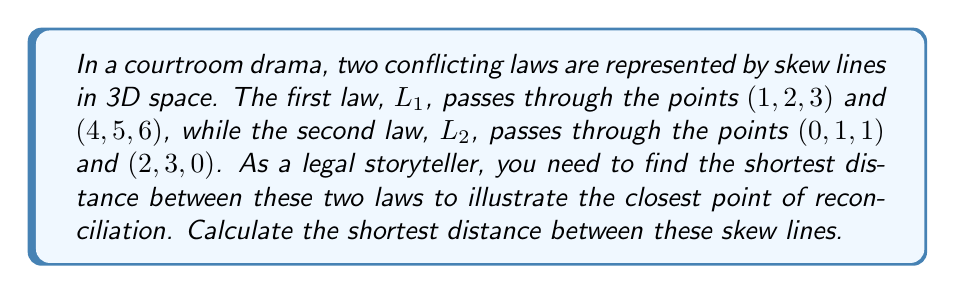Solve this math problem. To find the shortest distance between two skew lines in 3D space, we'll follow these steps:

1) First, let's define direction vectors for each line:
   For L1: $\vec{v} = (4-1, 5-2, 6-3) = (3, 3, 3)$
   For L2: $\vec{w} = (2-0, 3-1, 0-1) = (2, 2, -1)$

2) Now, we need to find a vector perpendicular to both lines. We can do this with the cross product:
   $\vec{n} = \vec{v} \times \vec{w} = \begin{vmatrix} 
   i & j & k \\
   3 & 3 & 3 \\
   2 & 2 & -1
   \end{vmatrix} = (3-9)i + (6+3)j + (6-6)k = (-6, 9, 0)$

3) Next, we need a point on each line. We can use the given points:
   P1 = (1, 2, 3) on L1
   P2 = (0, 1, 1) on L2

4) Now, we can find a vector connecting these points:
   $\vec{P_1P_2} = (0-1, 1-2, 1-3) = (-1, -1, -2)$

5) The shortest distance is the projection of $\vec{P_1P_2}$ onto $\vec{n}$:

   $d = \frac{|\vec{P_1P_2} \cdot \vec{n}|}{|\vec{n}|}$

6) Let's calculate this:
   $\vec{P_1P_2} \cdot \vec{n} = (-1)(-6) + (-1)(9) + (-2)(0) = 6 - 9 = -3$
   
   $|\vec{n}| = \sqrt{(-6)^2 + 9^2 + 0^2} = \sqrt{117}$

7) Therefore:
   $d = \frac{|-3|}{\sqrt{117}} = \frac{3}{\sqrt{117}}$

This distance represents the closest point of reconciliation between the two conflicting laws in our legal storytelling analogy.
Answer: The shortest distance between the two skew lines is $\frac{3}{\sqrt{117}}$ units. 